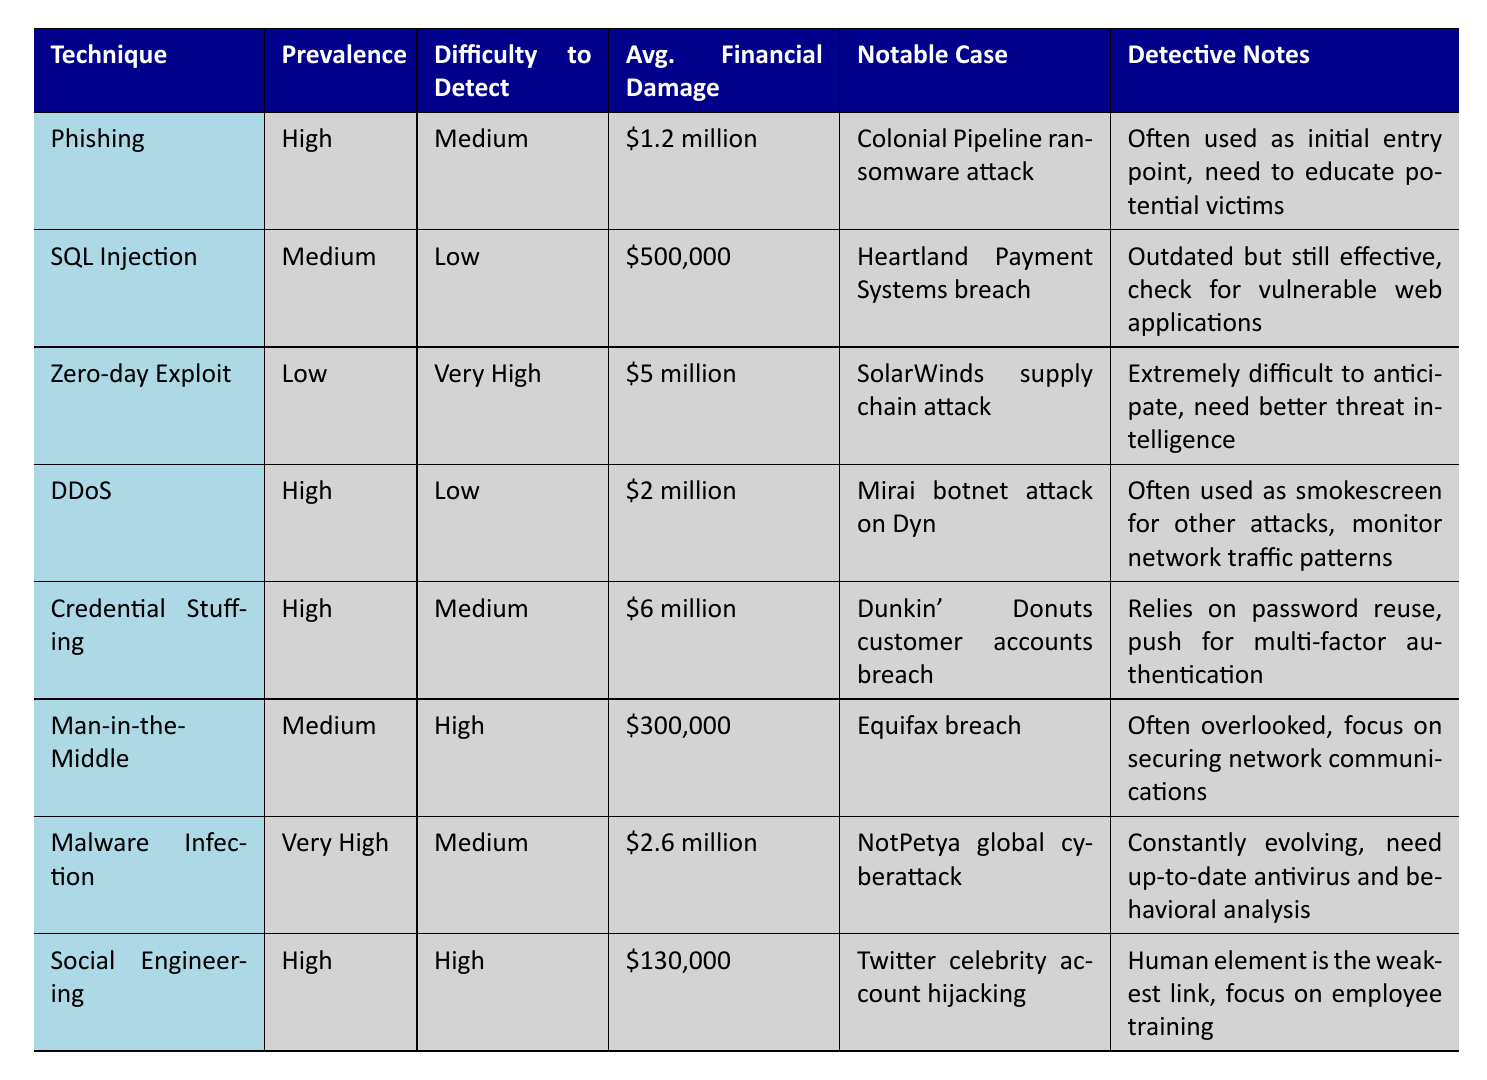What is the average financial damage caused by SQL Injection attacks? The average financial damage for SQL Injection is listed in the table as $500,000. Therefore, the answer is $500,000.
Answer: $500,000 Which hacking technique has the highest average financial damage? By comparing the average financial damage across all techniques, we see that Credential Stuffing has the highest average damage at $6 million.
Answer: Credential Stuffing Is the difficulty to detect a Zero-day Exploit considered low? The table indicates that the difficulty to detect a Zero-day Exploit is categorized as Very High, so the answer is no.
Answer: No What is the total average financial damage from high prevalence hacking techniques? The high prevalence techniques listed are Phishing ($1.2 million), DDoS ($2 million), Credential Stuffing ($6 million), and Social Engineering ($130,000). Adding these amounts gives $1.2M + $2M + $6M + $0.13M = $9.33 million.
Answer: $9.33 million How many hacking techniques have a difficulty to detect labeled as High? The table lists techniques with High detection difficulty. They are Man-in-the-Middle and Social Engineering. This means there are 2 techniques with High difficulty to detect.
Answer: 2 What notable case is associated with Malware Infection? The notable case related to Malware Infection in the table is the NotPetya global cyberattack.
Answer: NotPetya global cyberattack Is there a hacking technique that has both high prevalence and low difficulty to detect? Reviewing the table, Distributed Denial of Service (DDoS) is marked with high prevalence and low difficulty to detect, so the answer is yes.
Answer: Yes Which technique has the highest difficulty to detect and what is the notable case associated with it? The technique with the highest difficulty to detect is Zero-day Exploit, which has a difficulty level of Very High and is associated with the notable case of the SolarWinds supply chain attack.
Answer: Zero-day Exploit; SolarWinds supply chain attack 